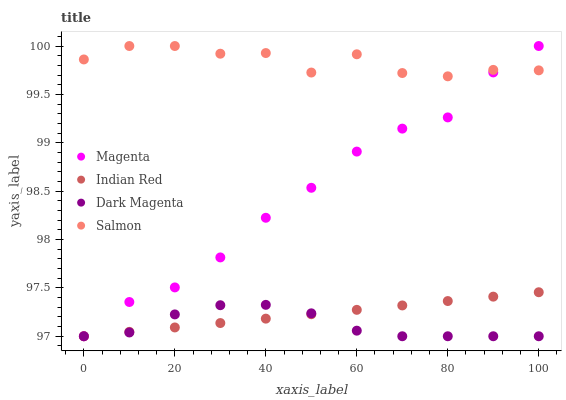Does Dark Magenta have the minimum area under the curve?
Answer yes or no. Yes. Does Salmon have the maximum area under the curve?
Answer yes or no. Yes. Does Salmon have the minimum area under the curve?
Answer yes or no. No. Does Dark Magenta have the maximum area under the curve?
Answer yes or no. No. Is Indian Red the smoothest?
Answer yes or no. Yes. Is Salmon the roughest?
Answer yes or no. Yes. Is Dark Magenta the smoothest?
Answer yes or no. No. Is Dark Magenta the roughest?
Answer yes or no. No. Does Magenta have the lowest value?
Answer yes or no. Yes. Does Salmon have the lowest value?
Answer yes or no. No. Does Salmon have the highest value?
Answer yes or no. Yes. Does Dark Magenta have the highest value?
Answer yes or no. No. Is Dark Magenta less than Salmon?
Answer yes or no. Yes. Is Salmon greater than Dark Magenta?
Answer yes or no. Yes. Does Magenta intersect Indian Red?
Answer yes or no. Yes. Is Magenta less than Indian Red?
Answer yes or no. No. Is Magenta greater than Indian Red?
Answer yes or no. No. Does Dark Magenta intersect Salmon?
Answer yes or no. No. 